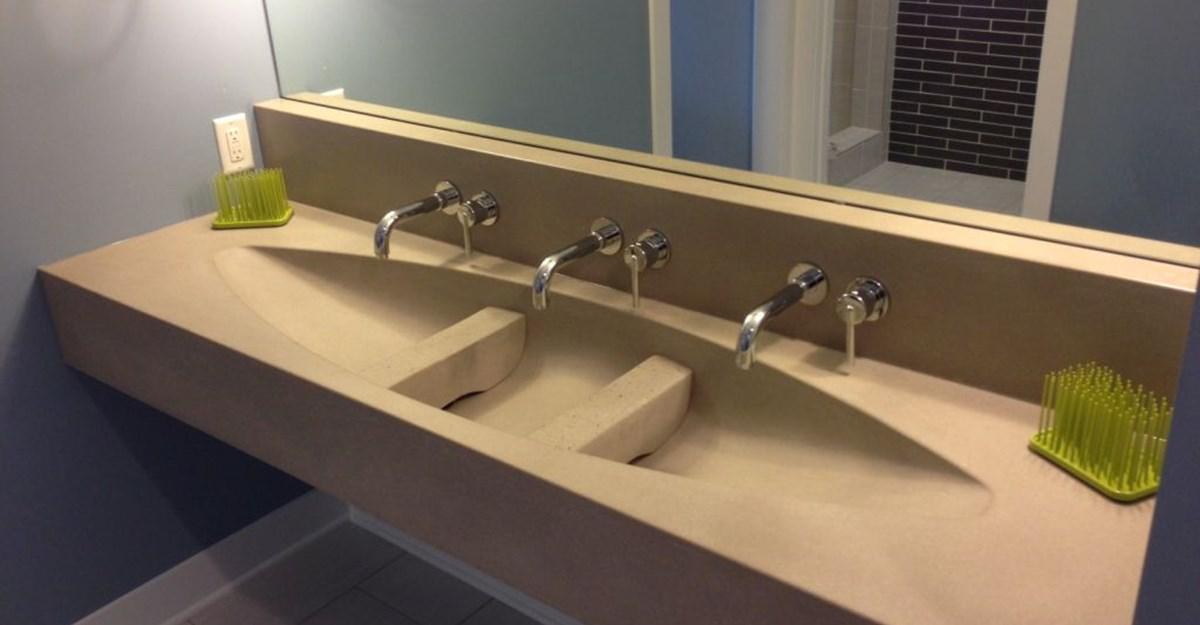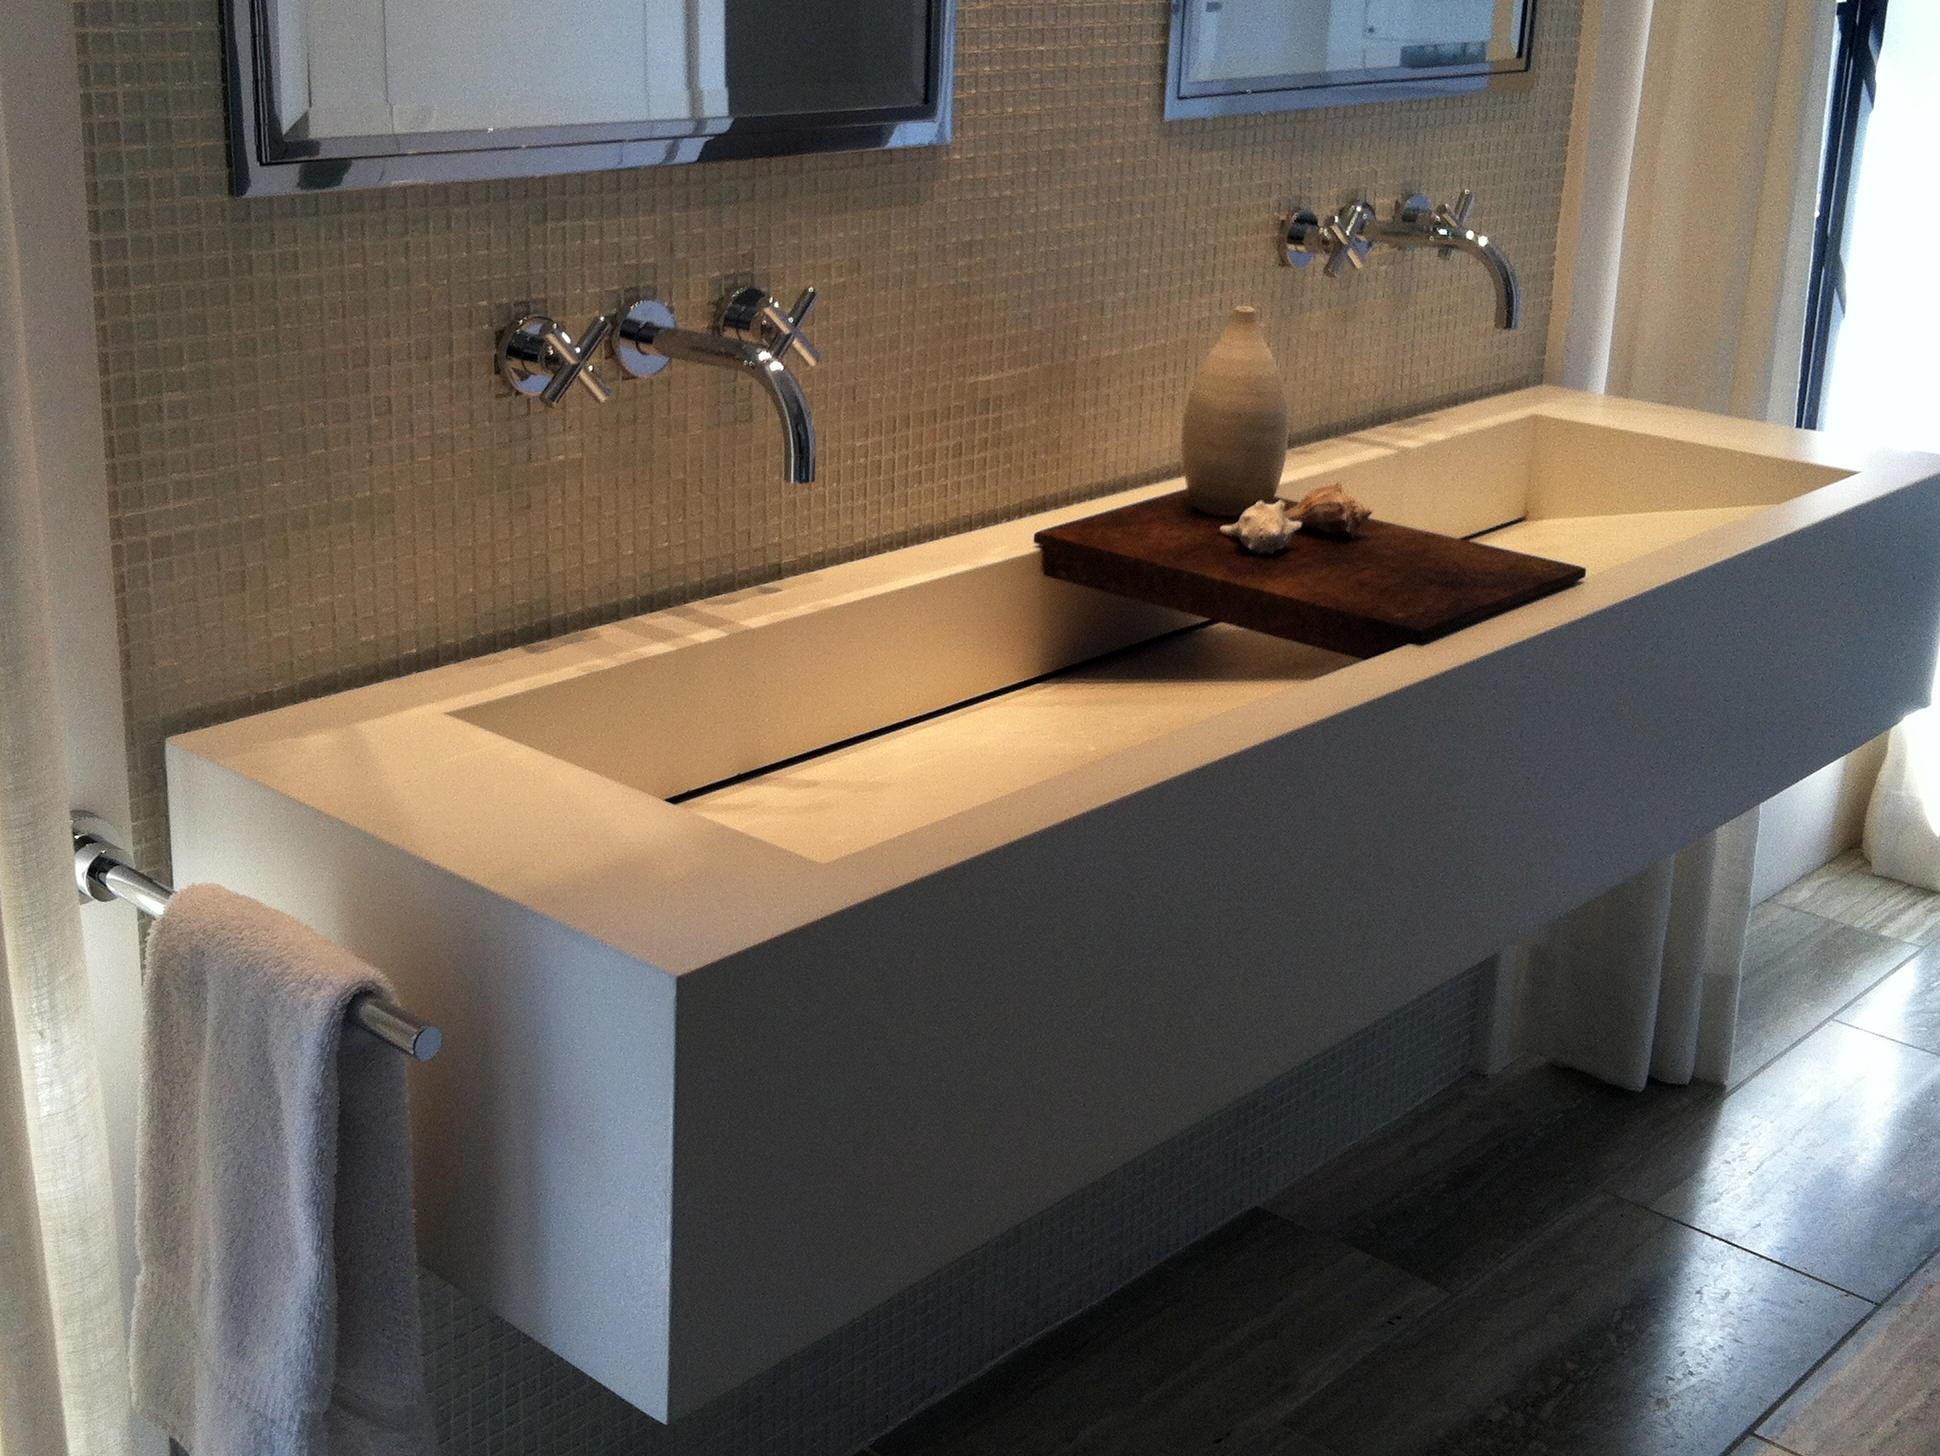The first image is the image on the left, the second image is the image on the right. Examine the images to the left and right. Is the description "One vanity features a long gray rectangular trough, with nothing dividing it and with two faucet and spout sets that are not wall-mounted." accurate? Answer yes or no. No. 